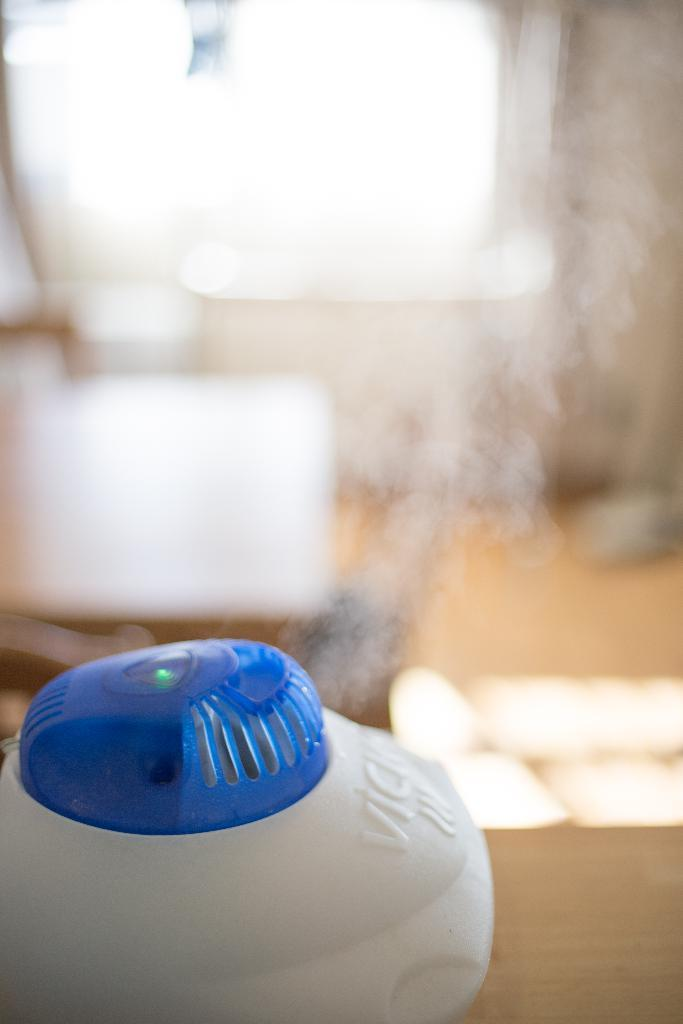What is located at the bottom of the image in the image? There is a table at the bottom of the image. What device is placed on the table? A mosquito killer is present on the table. What can be seen in the background of the image? There is smoke, a lamp, the floor, a wall, and a window visible in the background of the image. What type of weather can be seen through the window in the image? There is no indication of the weather in the image, as the window does not show any outdoor conditions. 